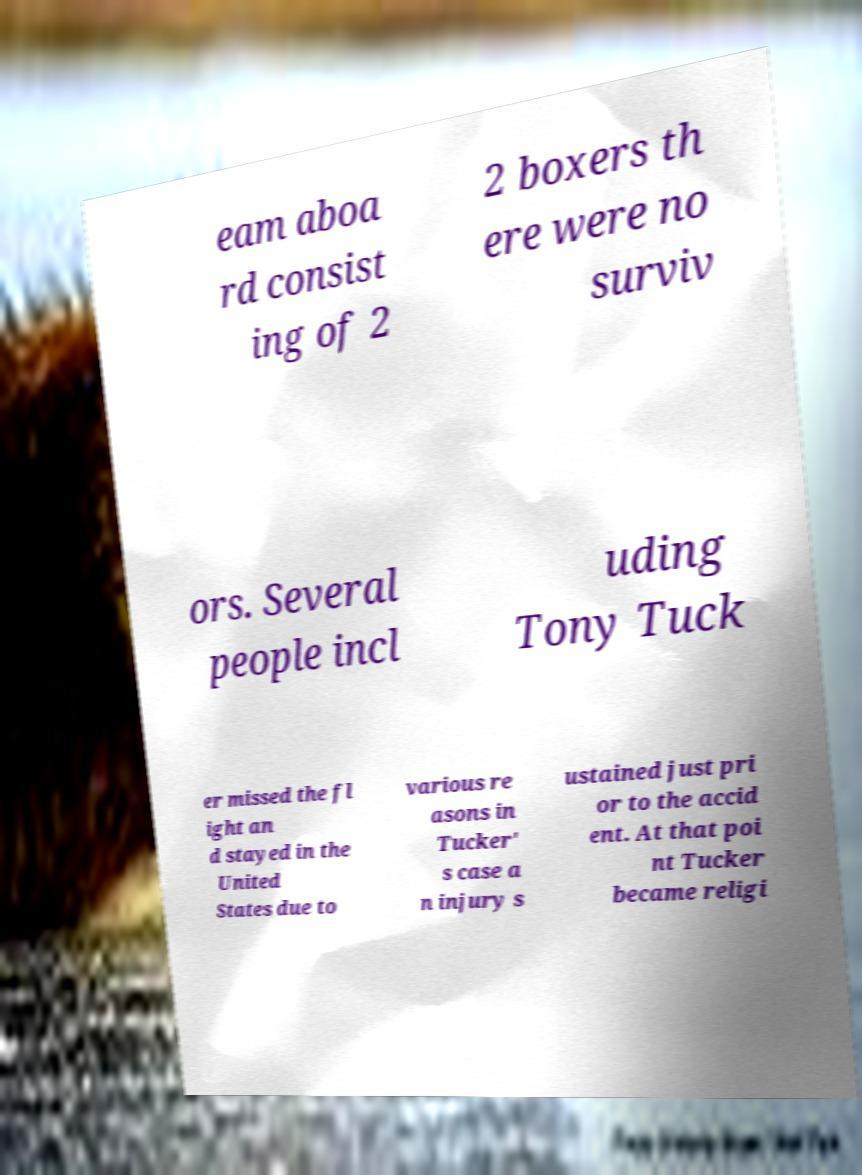For documentation purposes, I need the text within this image transcribed. Could you provide that? eam aboa rd consist ing of 2 2 boxers th ere were no surviv ors. Several people incl uding Tony Tuck er missed the fl ight an d stayed in the United States due to various re asons in Tucker' s case a n injury s ustained just pri or to the accid ent. At that poi nt Tucker became religi 